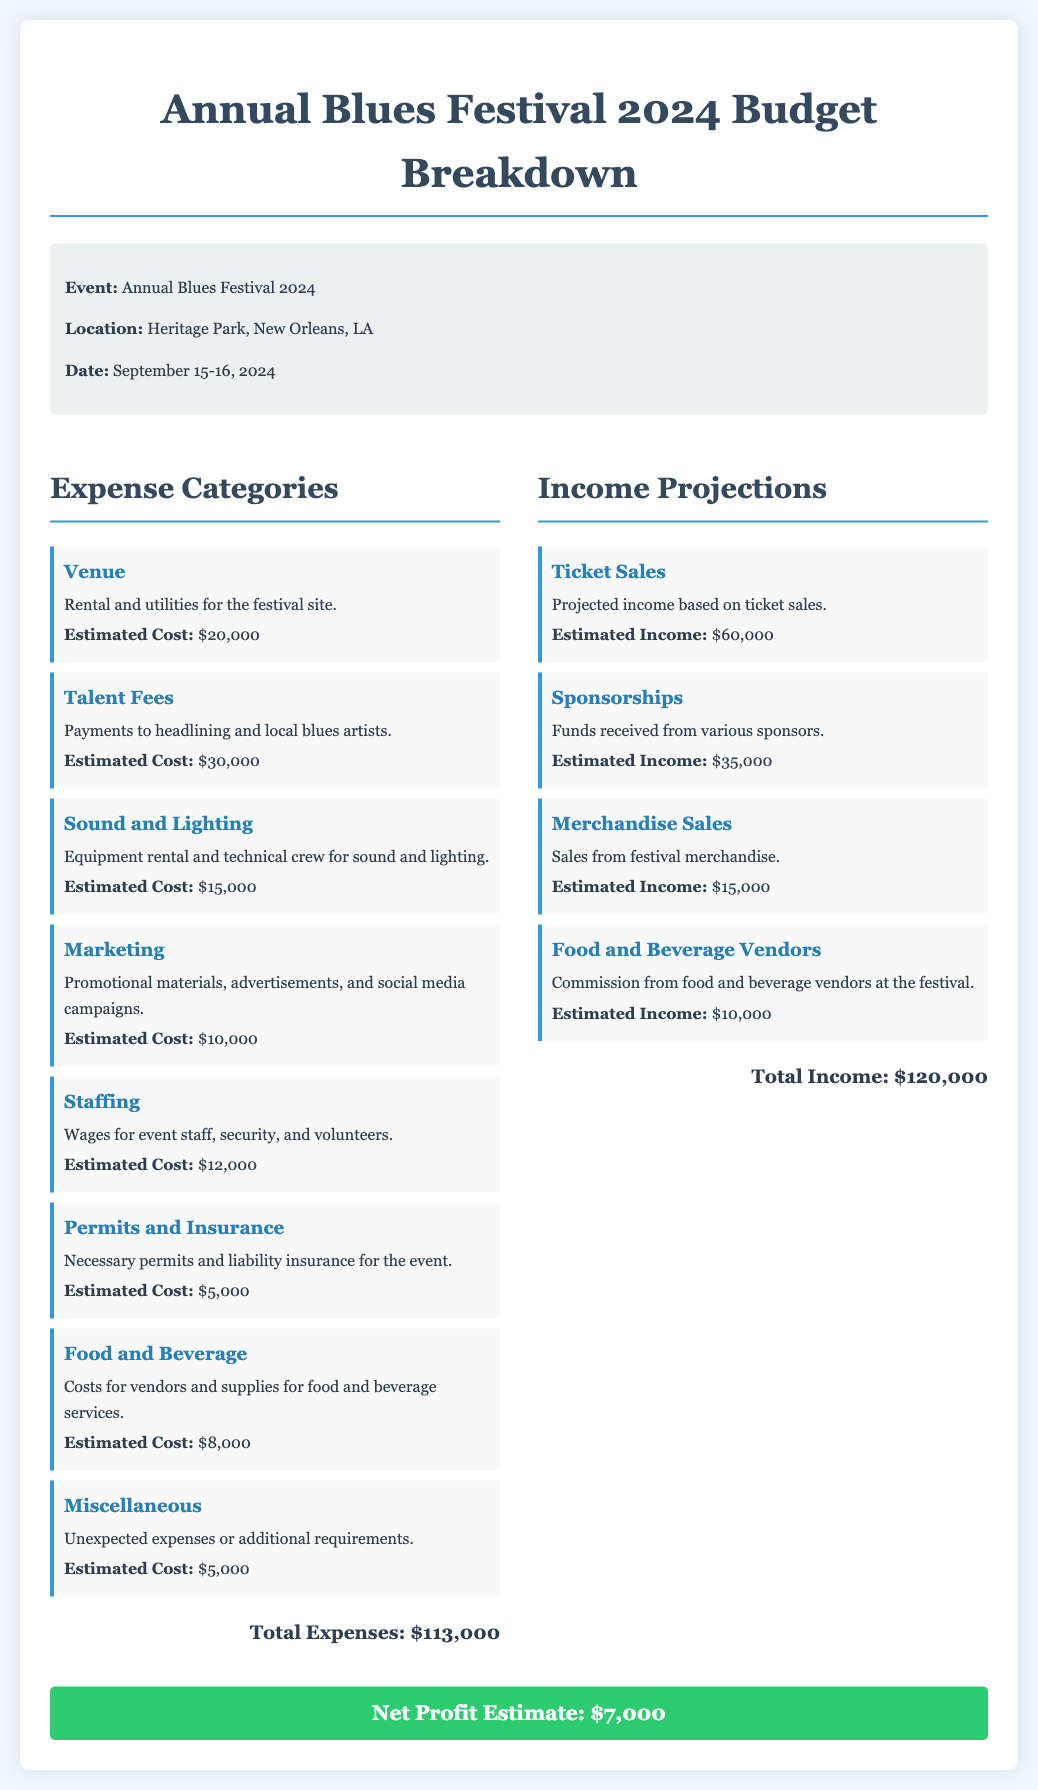What is the estimated cost for venue rental? The estimated cost for venue rental is explicitly mentioned in the expense category for "Venue."
Answer: $20,000 What are the total expenses listed in the document? The total expenses are summarized at the end of the expense section, aggregating all costs.
Answer: $113,000 What is the date of the Annual Blues Festival? The date of the festival is provided in the event details section in a specific format.
Answer: September 15-16, 2024 How much is projected from ticket sales? The projected income from ticket sales is clearly indicated in the income projections section.
Answer: $60,000 What is the estimated net profit for the festival? The net profit estimate is provided as a summary at the end of the budget breakdown.
Answer: $7,000 What is the estimated cost for marketing? The estimated cost for marketing is detailed in the expenses, specifying what it covers.
Answer: $10,000 What is the budget category that includes staffing wages? The budget category that includes staff wages is labeled under "Staffing" in the expenses.
Answer: Staffing What are the total income projections? The total income from all sources is calculated and listed at the end of the income section.
Answer: $120,000 How much is expected from merchandise sales? The expected income from merchandise sales is presented in the income projections section.
Answer: $15,000 